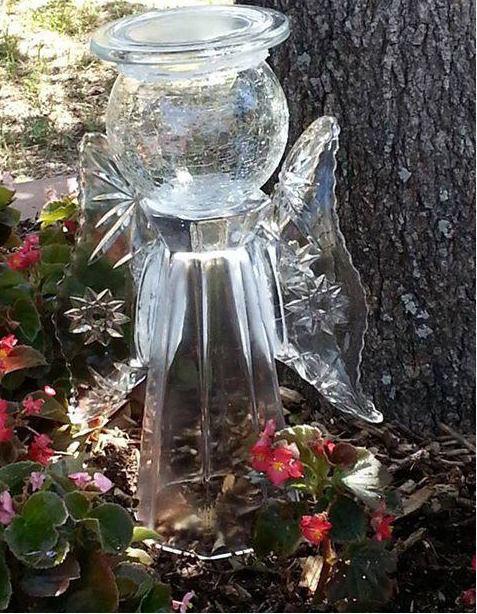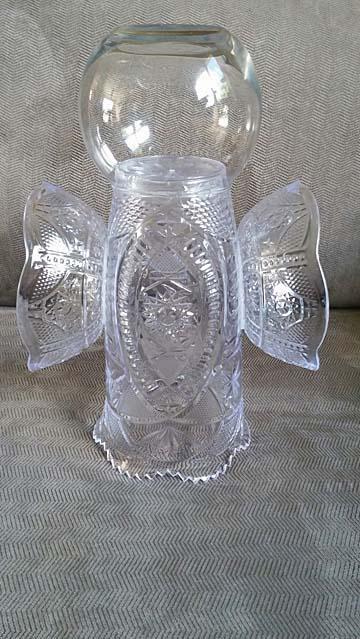The first image is the image on the left, the second image is the image on the right. For the images shown, is this caption "One image features a tower of stacked glass vases and pedestals in various colors, and the stacked glassware does not combine to form a human-like figure." true? Answer yes or no. No. The first image is the image on the left, the second image is the image on the right. For the images shown, is this caption "In at least one image there is a glass angel looking vase that is touch leaves and dirt on the ground." true? Answer yes or no. Yes. 